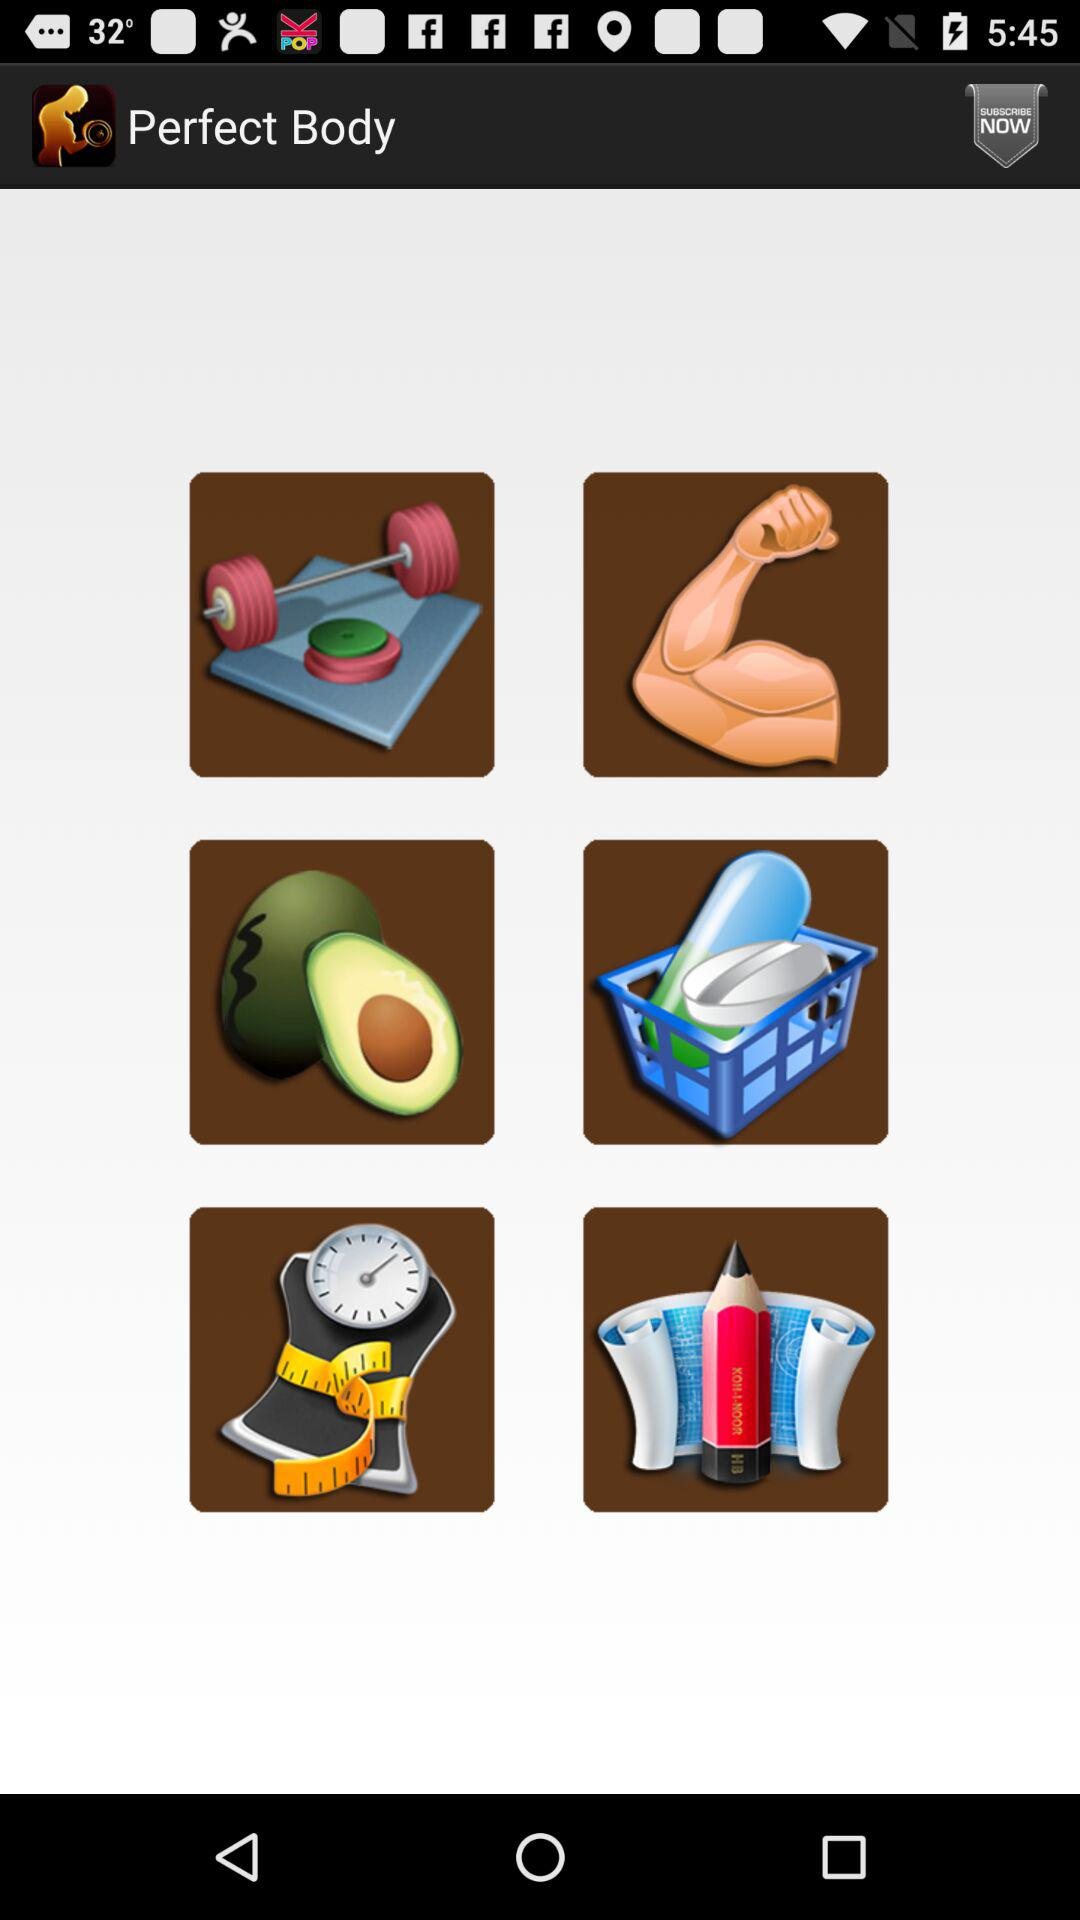How many calories must be burned to get the perfect body?
When the provided information is insufficient, respond with <no answer>. <no answer> 